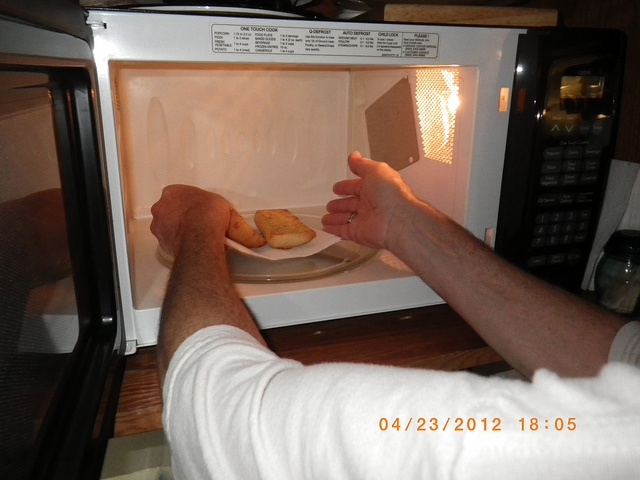Describe the objects in this image and their specific colors. I can see microwave in black, tan, darkgray, and gray tones and people in black, lightgray, maroon, and brown tones in this image. 